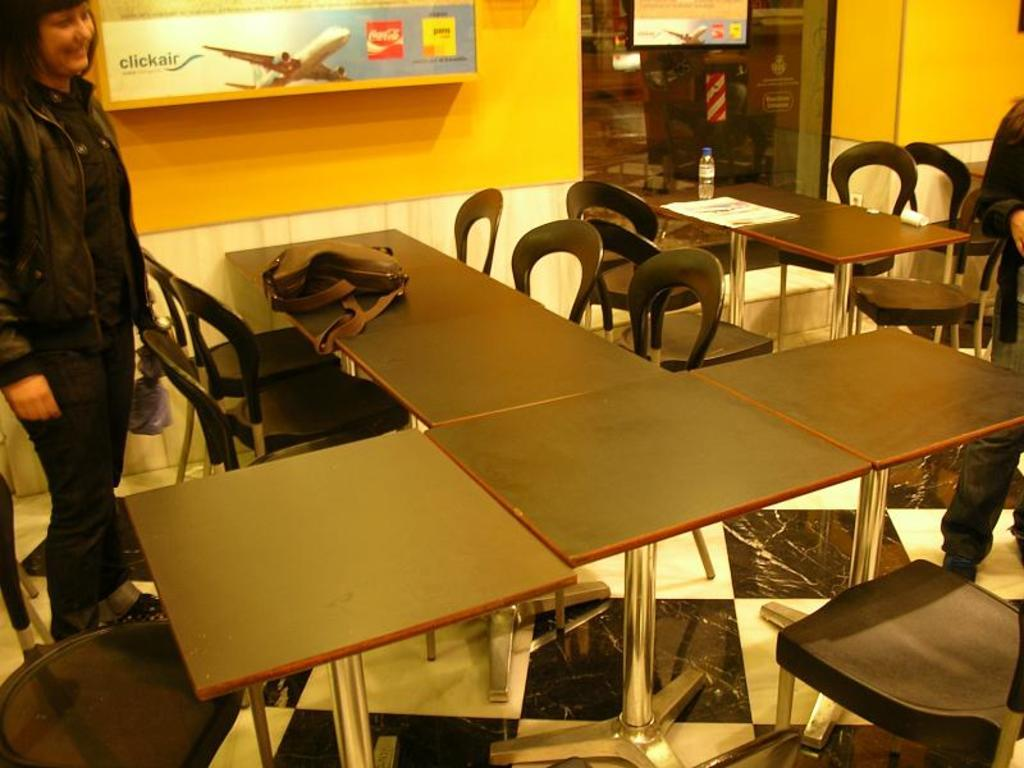What is the person in the image doing? The person is standing on the floor and smiling. What is in front of the person? There is a table in front of the person. What is on the table? There is a bag on the table. What is next to the person? There is a wall next to the person. What is on the wall? There is a board on the wall. How many snails can be seen crawling on the person's tongue in the image? There are no snails visible in the image, and the person's tongue is not shown. What type of leaf is hanging from the board on the wall? There is no leaf present in the image; only the board is visible on the wall. 